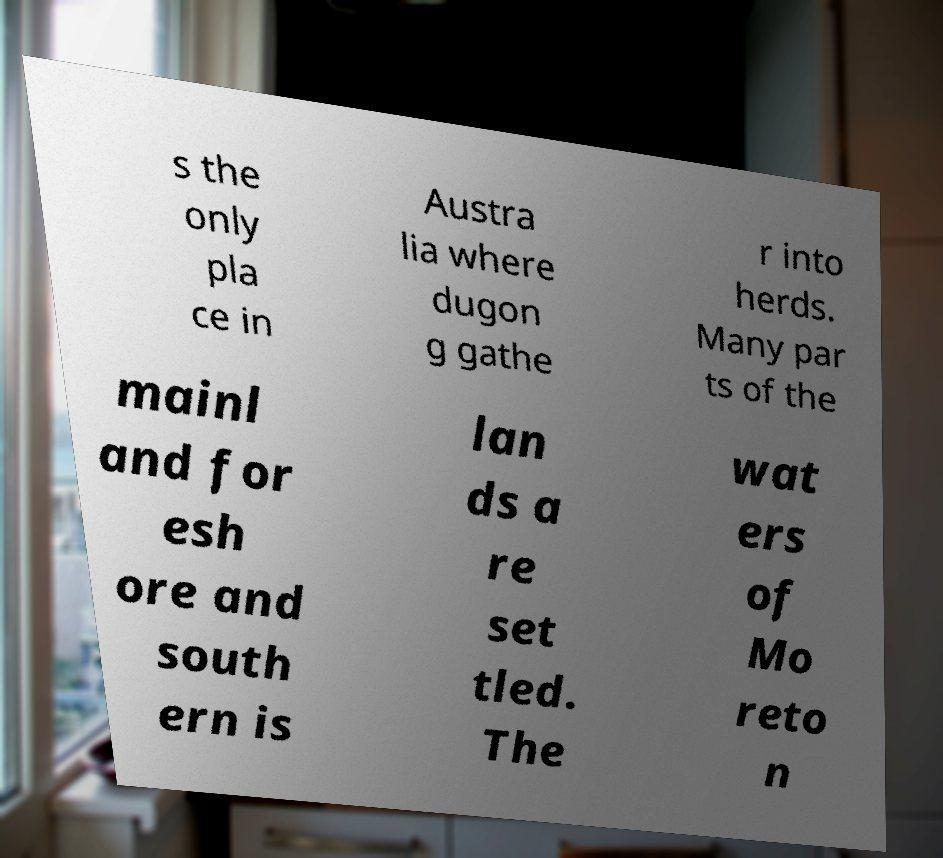What messages or text are displayed in this image? I need them in a readable, typed format. s the only pla ce in Austra lia where dugon g gathe r into herds. Many par ts of the mainl and for esh ore and south ern is lan ds a re set tled. The wat ers of Mo reto n 